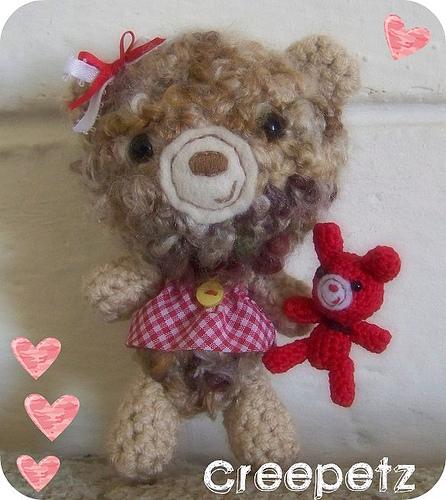Where is the heart?
Quick response, please. In corners. What is the teddy bear holding?
Short answer required. Teddy bear. What shape is the teddy bear's head?
Give a very brief answer. Round. What type of animal is this?
Quick response, please. Bear. 